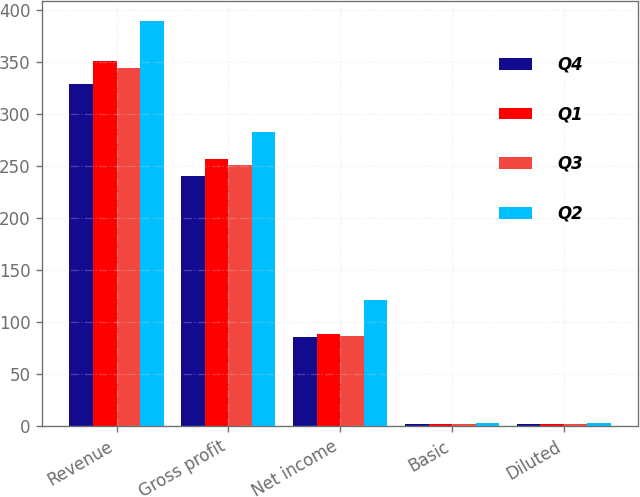Convert chart. <chart><loc_0><loc_0><loc_500><loc_500><stacked_bar_chart><ecel><fcel>Revenue<fcel>Gross profit<fcel>Net income<fcel>Basic<fcel>Diluted<nl><fcel>Q4<fcel>328.6<fcel>240.5<fcel>85.3<fcel>2.2<fcel>2.12<nl><fcel>Q1<fcel>350.7<fcel>256.8<fcel>88.7<fcel>2.26<fcel>2.19<nl><fcel>Q3<fcel>344.4<fcel>250.6<fcel>86.6<fcel>2.2<fcel>2.14<nl><fcel>Q2<fcel>389.3<fcel>282.1<fcel>121.2<fcel>3.1<fcel>3.02<nl></chart> 